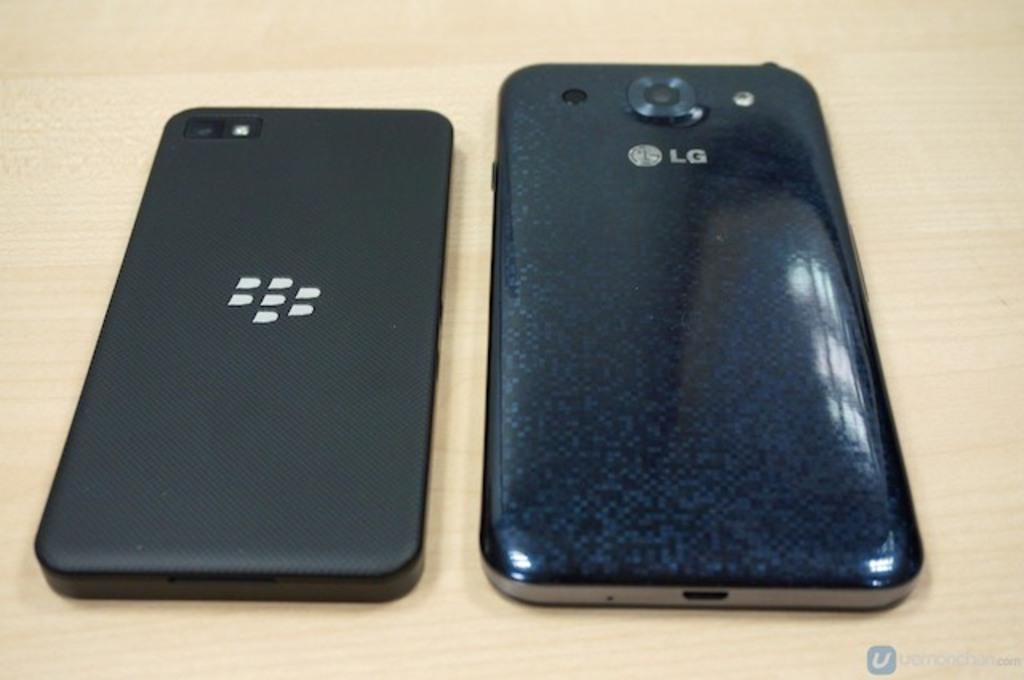Provide a one-sentence caption for the provided image. the backs of two black cell phones with one reading LG. 